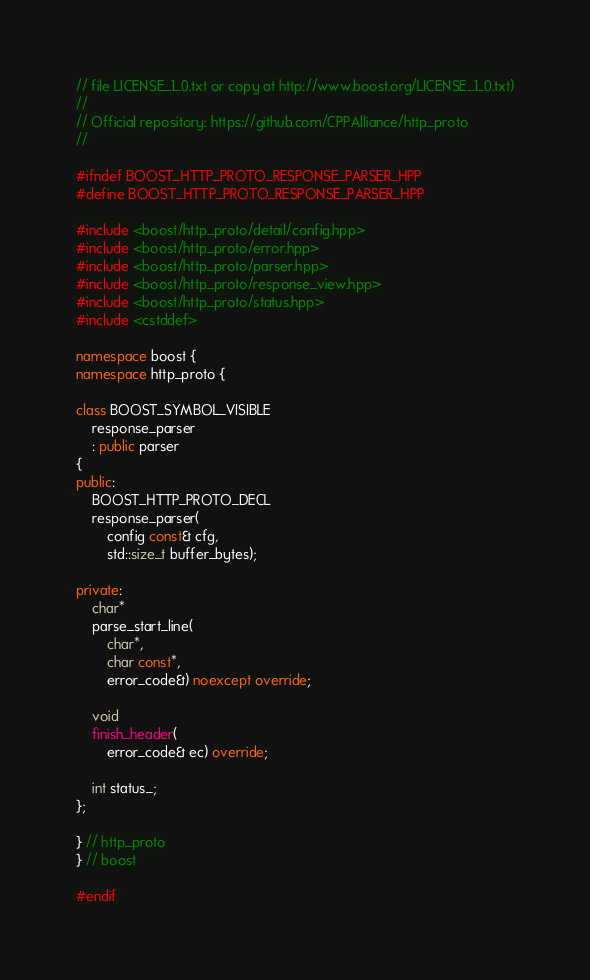Convert code to text. <code><loc_0><loc_0><loc_500><loc_500><_C++_>// file LICENSE_1_0.txt or copy at http://www.boost.org/LICENSE_1_0.txt)
//
// Official repository: https://github.com/CPPAlliance/http_proto
//

#ifndef BOOST_HTTP_PROTO_RESPONSE_PARSER_HPP
#define BOOST_HTTP_PROTO_RESPONSE_PARSER_HPP

#include <boost/http_proto/detail/config.hpp>
#include <boost/http_proto/error.hpp>
#include <boost/http_proto/parser.hpp>
#include <boost/http_proto/response_view.hpp>
#include <boost/http_proto/status.hpp>
#include <cstddef>

namespace boost {
namespace http_proto {

class BOOST_SYMBOL_VISIBLE
    response_parser
    : public parser
{
public:
    BOOST_HTTP_PROTO_DECL
    response_parser(
        config const& cfg,
        std::size_t buffer_bytes);

private:
    char*
    parse_start_line(
        char*,
        char const*,
        error_code&) noexcept override;

    void
    finish_header(
        error_code& ec) override;

    int status_;
};

} // http_proto
} // boost

#endif
</code> 